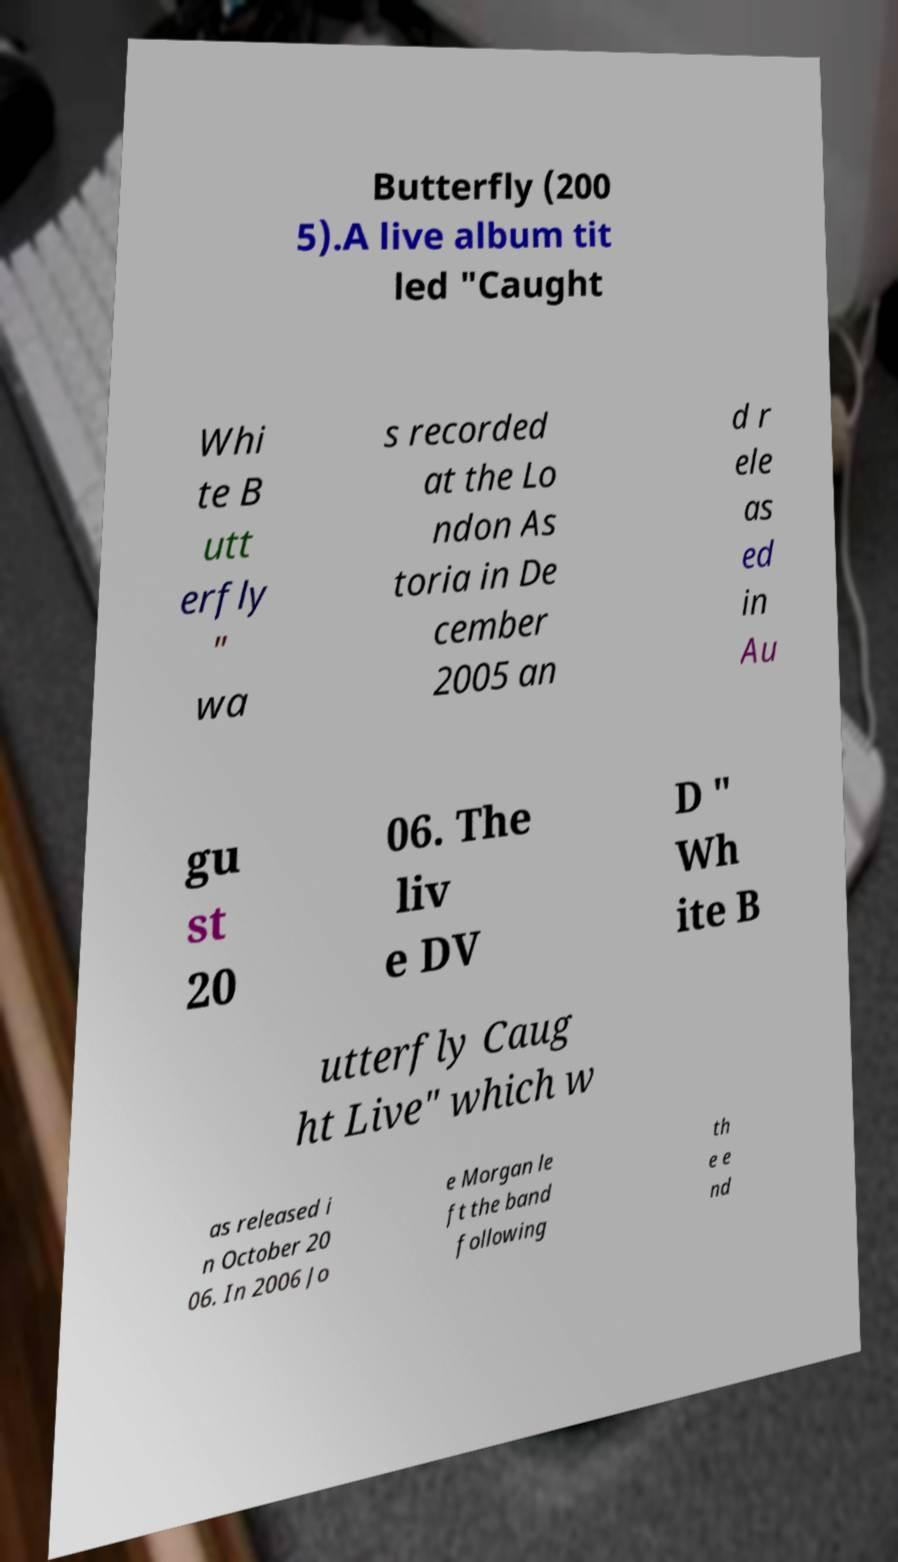What messages or text are displayed in this image? I need them in a readable, typed format. Butterfly (200 5).A live album tit led "Caught Whi te B utt erfly " wa s recorded at the Lo ndon As toria in De cember 2005 an d r ele as ed in Au gu st 20 06. The liv e DV D " Wh ite B utterfly Caug ht Live" which w as released i n October 20 06. In 2006 Jo e Morgan le ft the band following th e e nd 